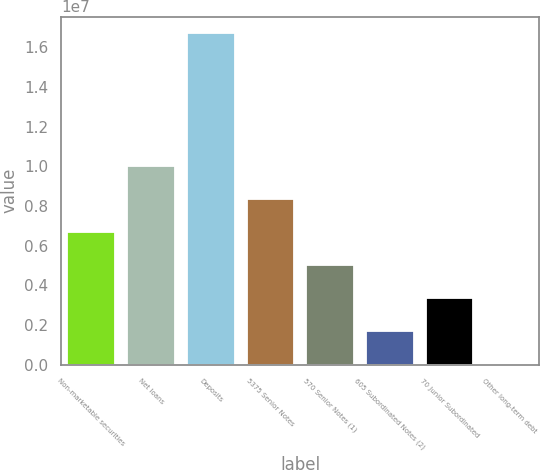Convert chart. <chart><loc_0><loc_0><loc_500><loc_500><bar_chart><fcel>Non-marketable securities<fcel>Net loans<fcel>Deposits<fcel>5375 Senior Notes<fcel>570 Senior Notes (1)<fcel>605 Subordinated Notes (2)<fcel>70 Junior Subordinated<fcel>Other long-term debt<nl><fcel>6.68468e+06<fcel>1.00263e+07<fcel>1.67095e+07<fcel>8.35549e+06<fcel>5.01387e+06<fcel>1.67225e+06<fcel>3.34306e+06<fcel>1439<nl></chart> 